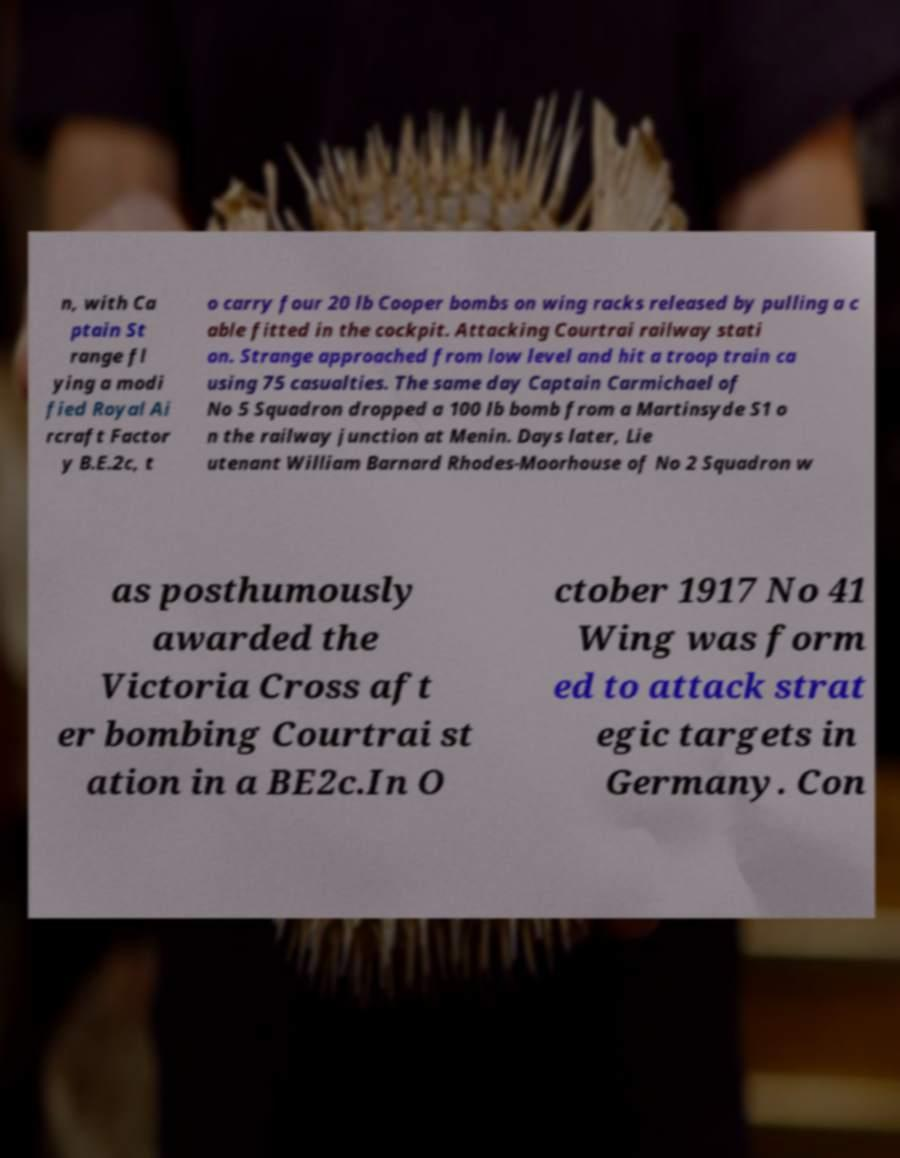Could you assist in decoding the text presented in this image and type it out clearly? n, with Ca ptain St range fl ying a modi fied Royal Ai rcraft Factor y B.E.2c, t o carry four 20 lb Cooper bombs on wing racks released by pulling a c able fitted in the cockpit. Attacking Courtrai railway stati on. Strange approached from low level and hit a troop train ca using 75 casualties. The same day Captain Carmichael of No 5 Squadron dropped a 100 lb bomb from a Martinsyde S1 o n the railway junction at Menin. Days later, Lie utenant William Barnard Rhodes-Moorhouse of No 2 Squadron w as posthumously awarded the Victoria Cross aft er bombing Courtrai st ation in a BE2c.In O ctober 1917 No 41 Wing was form ed to attack strat egic targets in Germany. Con 